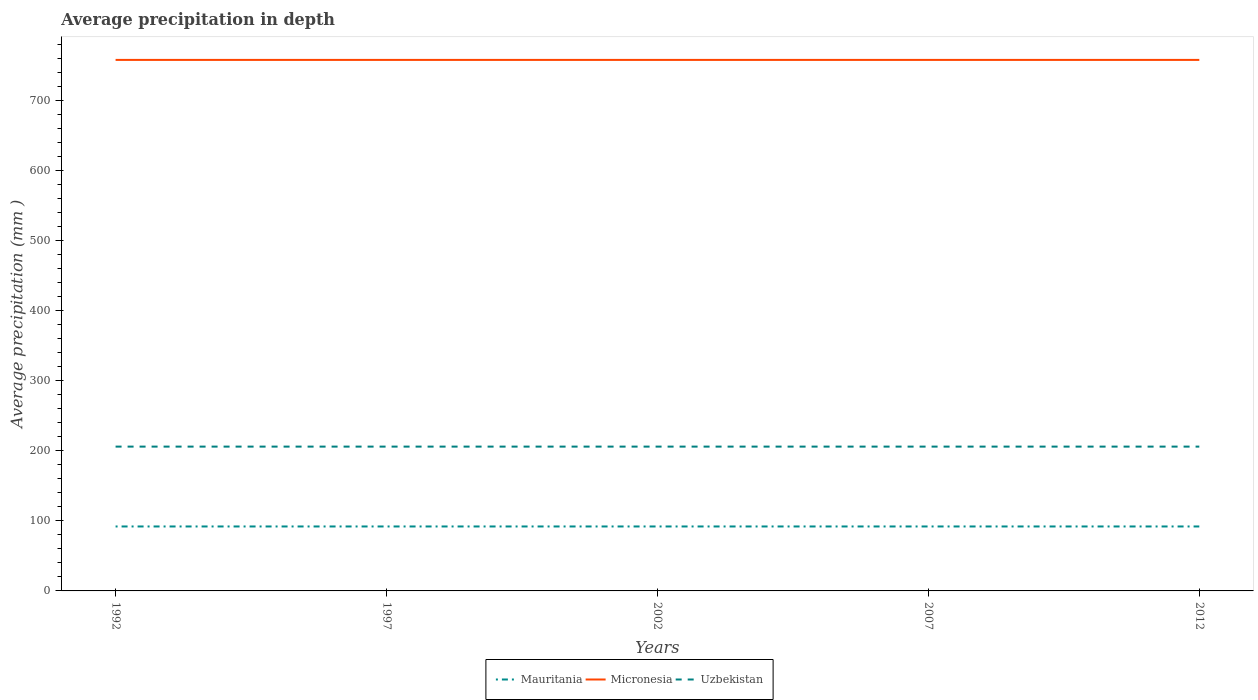How many different coloured lines are there?
Provide a short and direct response. 3. Is the number of lines equal to the number of legend labels?
Offer a very short reply. Yes. Across all years, what is the maximum average precipitation in Uzbekistan?
Ensure brevity in your answer.  206. In which year was the average precipitation in Mauritania maximum?
Offer a very short reply. 1992. What is the total average precipitation in Micronesia in the graph?
Offer a terse response. 0. What is the difference between the highest and the second highest average precipitation in Mauritania?
Your answer should be compact. 0. Is the average precipitation in Uzbekistan strictly greater than the average precipitation in Micronesia over the years?
Your response must be concise. Yes. Are the values on the major ticks of Y-axis written in scientific E-notation?
Offer a terse response. No. Does the graph contain any zero values?
Provide a succinct answer. No. Does the graph contain grids?
Your answer should be compact. No. How many legend labels are there?
Provide a short and direct response. 3. How are the legend labels stacked?
Ensure brevity in your answer.  Horizontal. What is the title of the graph?
Provide a short and direct response. Average precipitation in depth. What is the label or title of the Y-axis?
Give a very brief answer. Average precipitation (mm ). What is the Average precipitation (mm ) of Mauritania in 1992?
Provide a succinct answer. 92. What is the Average precipitation (mm ) of Micronesia in 1992?
Provide a succinct answer. 758. What is the Average precipitation (mm ) of Uzbekistan in 1992?
Your answer should be very brief. 206. What is the Average precipitation (mm ) of Mauritania in 1997?
Give a very brief answer. 92. What is the Average precipitation (mm ) in Micronesia in 1997?
Offer a very short reply. 758. What is the Average precipitation (mm ) of Uzbekistan in 1997?
Your answer should be compact. 206. What is the Average precipitation (mm ) in Mauritania in 2002?
Make the answer very short. 92. What is the Average precipitation (mm ) in Micronesia in 2002?
Your answer should be very brief. 758. What is the Average precipitation (mm ) of Uzbekistan in 2002?
Offer a terse response. 206. What is the Average precipitation (mm ) of Mauritania in 2007?
Give a very brief answer. 92. What is the Average precipitation (mm ) of Micronesia in 2007?
Provide a short and direct response. 758. What is the Average precipitation (mm ) of Uzbekistan in 2007?
Provide a short and direct response. 206. What is the Average precipitation (mm ) of Mauritania in 2012?
Offer a terse response. 92. What is the Average precipitation (mm ) of Micronesia in 2012?
Provide a short and direct response. 758. What is the Average precipitation (mm ) in Uzbekistan in 2012?
Provide a short and direct response. 206. Across all years, what is the maximum Average precipitation (mm ) in Mauritania?
Your response must be concise. 92. Across all years, what is the maximum Average precipitation (mm ) in Micronesia?
Make the answer very short. 758. Across all years, what is the maximum Average precipitation (mm ) in Uzbekistan?
Offer a very short reply. 206. Across all years, what is the minimum Average precipitation (mm ) in Mauritania?
Make the answer very short. 92. Across all years, what is the minimum Average precipitation (mm ) of Micronesia?
Your response must be concise. 758. Across all years, what is the minimum Average precipitation (mm ) in Uzbekistan?
Make the answer very short. 206. What is the total Average precipitation (mm ) of Mauritania in the graph?
Give a very brief answer. 460. What is the total Average precipitation (mm ) in Micronesia in the graph?
Offer a very short reply. 3790. What is the total Average precipitation (mm ) of Uzbekistan in the graph?
Provide a succinct answer. 1030. What is the difference between the Average precipitation (mm ) of Micronesia in 1992 and that in 1997?
Your answer should be compact. 0. What is the difference between the Average precipitation (mm ) of Uzbekistan in 1992 and that in 1997?
Your response must be concise. 0. What is the difference between the Average precipitation (mm ) of Micronesia in 1992 and that in 2002?
Your answer should be compact. 0. What is the difference between the Average precipitation (mm ) of Uzbekistan in 1992 and that in 2002?
Provide a short and direct response. 0. What is the difference between the Average precipitation (mm ) in Micronesia in 1992 and that in 2007?
Your answer should be very brief. 0. What is the difference between the Average precipitation (mm ) in Uzbekistan in 1992 and that in 2007?
Provide a succinct answer. 0. What is the difference between the Average precipitation (mm ) of Mauritania in 1992 and that in 2012?
Your response must be concise. 0. What is the difference between the Average precipitation (mm ) of Mauritania in 1997 and that in 2002?
Your response must be concise. 0. What is the difference between the Average precipitation (mm ) in Uzbekistan in 1997 and that in 2007?
Your answer should be very brief. 0. What is the difference between the Average precipitation (mm ) in Micronesia in 2002 and that in 2007?
Ensure brevity in your answer.  0. What is the difference between the Average precipitation (mm ) of Mauritania in 2002 and that in 2012?
Make the answer very short. 0. What is the difference between the Average precipitation (mm ) of Micronesia in 2002 and that in 2012?
Make the answer very short. 0. What is the difference between the Average precipitation (mm ) of Micronesia in 2007 and that in 2012?
Ensure brevity in your answer.  0. What is the difference between the Average precipitation (mm ) in Uzbekistan in 2007 and that in 2012?
Give a very brief answer. 0. What is the difference between the Average precipitation (mm ) of Mauritania in 1992 and the Average precipitation (mm ) of Micronesia in 1997?
Provide a succinct answer. -666. What is the difference between the Average precipitation (mm ) of Mauritania in 1992 and the Average precipitation (mm ) of Uzbekistan in 1997?
Make the answer very short. -114. What is the difference between the Average precipitation (mm ) of Micronesia in 1992 and the Average precipitation (mm ) of Uzbekistan in 1997?
Give a very brief answer. 552. What is the difference between the Average precipitation (mm ) in Mauritania in 1992 and the Average precipitation (mm ) in Micronesia in 2002?
Provide a short and direct response. -666. What is the difference between the Average precipitation (mm ) in Mauritania in 1992 and the Average precipitation (mm ) in Uzbekistan in 2002?
Ensure brevity in your answer.  -114. What is the difference between the Average precipitation (mm ) in Micronesia in 1992 and the Average precipitation (mm ) in Uzbekistan in 2002?
Offer a terse response. 552. What is the difference between the Average precipitation (mm ) in Mauritania in 1992 and the Average precipitation (mm ) in Micronesia in 2007?
Your answer should be very brief. -666. What is the difference between the Average precipitation (mm ) in Mauritania in 1992 and the Average precipitation (mm ) in Uzbekistan in 2007?
Your answer should be very brief. -114. What is the difference between the Average precipitation (mm ) in Micronesia in 1992 and the Average precipitation (mm ) in Uzbekistan in 2007?
Provide a short and direct response. 552. What is the difference between the Average precipitation (mm ) in Mauritania in 1992 and the Average precipitation (mm ) in Micronesia in 2012?
Offer a very short reply. -666. What is the difference between the Average precipitation (mm ) in Mauritania in 1992 and the Average precipitation (mm ) in Uzbekistan in 2012?
Offer a very short reply. -114. What is the difference between the Average precipitation (mm ) in Micronesia in 1992 and the Average precipitation (mm ) in Uzbekistan in 2012?
Your answer should be compact. 552. What is the difference between the Average precipitation (mm ) of Mauritania in 1997 and the Average precipitation (mm ) of Micronesia in 2002?
Offer a terse response. -666. What is the difference between the Average precipitation (mm ) in Mauritania in 1997 and the Average precipitation (mm ) in Uzbekistan in 2002?
Give a very brief answer. -114. What is the difference between the Average precipitation (mm ) of Micronesia in 1997 and the Average precipitation (mm ) of Uzbekistan in 2002?
Give a very brief answer. 552. What is the difference between the Average precipitation (mm ) of Mauritania in 1997 and the Average precipitation (mm ) of Micronesia in 2007?
Give a very brief answer. -666. What is the difference between the Average precipitation (mm ) in Mauritania in 1997 and the Average precipitation (mm ) in Uzbekistan in 2007?
Your response must be concise. -114. What is the difference between the Average precipitation (mm ) in Micronesia in 1997 and the Average precipitation (mm ) in Uzbekistan in 2007?
Offer a terse response. 552. What is the difference between the Average precipitation (mm ) in Mauritania in 1997 and the Average precipitation (mm ) in Micronesia in 2012?
Make the answer very short. -666. What is the difference between the Average precipitation (mm ) of Mauritania in 1997 and the Average precipitation (mm ) of Uzbekistan in 2012?
Your answer should be compact. -114. What is the difference between the Average precipitation (mm ) in Micronesia in 1997 and the Average precipitation (mm ) in Uzbekistan in 2012?
Make the answer very short. 552. What is the difference between the Average precipitation (mm ) in Mauritania in 2002 and the Average precipitation (mm ) in Micronesia in 2007?
Your response must be concise. -666. What is the difference between the Average precipitation (mm ) in Mauritania in 2002 and the Average precipitation (mm ) in Uzbekistan in 2007?
Provide a short and direct response. -114. What is the difference between the Average precipitation (mm ) of Micronesia in 2002 and the Average precipitation (mm ) of Uzbekistan in 2007?
Provide a short and direct response. 552. What is the difference between the Average precipitation (mm ) of Mauritania in 2002 and the Average precipitation (mm ) of Micronesia in 2012?
Offer a very short reply. -666. What is the difference between the Average precipitation (mm ) in Mauritania in 2002 and the Average precipitation (mm ) in Uzbekistan in 2012?
Make the answer very short. -114. What is the difference between the Average precipitation (mm ) of Micronesia in 2002 and the Average precipitation (mm ) of Uzbekistan in 2012?
Provide a succinct answer. 552. What is the difference between the Average precipitation (mm ) of Mauritania in 2007 and the Average precipitation (mm ) of Micronesia in 2012?
Keep it short and to the point. -666. What is the difference between the Average precipitation (mm ) in Mauritania in 2007 and the Average precipitation (mm ) in Uzbekistan in 2012?
Offer a very short reply. -114. What is the difference between the Average precipitation (mm ) in Micronesia in 2007 and the Average precipitation (mm ) in Uzbekistan in 2012?
Offer a terse response. 552. What is the average Average precipitation (mm ) in Mauritania per year?
Ensure brevity in your answer.  92. What is the average Average precipitation (mm ) of Micronesia per year?
Make the answer very short. 758. What is the average Average precipitation (mm ) of Uzbekistan per year?
Provide a short and direct response. 206. In the year 1992, what is the difference between the Average precipitation (mm ) in Mauritania and Average precipitation (mm ) in Micronesia?
Give a very brief answer. -666. In the year 1992, what is the difference between the Average precipitation (mm ) in Mauritania and Average precipitation (mm ) in Uzbekistan?
Provide a short and direct response. -114. In the year 1992, what is the difference between the Average precipitation (mm ) of Micronesia and Average precipitation (mm ) of Uzbekistan?
Provide a short and direct response. 552. In the year 1997, what is the difference between the Average precipitation (mm ) in Mauritania and Average precipitation (mm ) in Micronesia?
Offer a very short reply. -666. In the year 1997, what is the difference between the Average precipitation (mm ) in Mauritania and Average precipitation (mm ) in Uzbekistan?
Your answer should be compact. -114. In the year 1997, what is the difference between the Average precipitation (mm ) in Micronesia and Average precipitation (mm ) in Uzbekistan?
Offer a very short reply. 552. In the year 2002, what is the difference between the Average precipitation (mm ) in Mauritania and Average precipitation (mm ) in Micronesia?
Ensure brevity in your answer.  -666. In the year 2002, what is the difference between the Average precipitation (mm ) of Mauritania and Average precipitation (mm ) of Uzbekistan?
Your answer should be compact. -114. In the year 2002, what is the difference between the Average precipitation (mm ) in Micronesia and Average precipitation (mm ) in Uzbekistan?
Provide a short and direct response. 552. In the year 2007, what is the difference between the Average precipitation (mm ) in Mauritania and Average precipitation (mm ) in Micronesia?
Keep it short and to the point. -666. In the year 2007, what is the difference between the Average precipitation (mm ) in Mauritania and Average precipitation (mm ) in Uzbekistan?
Give a very brief answer. -114. In the year 2007, what is the difference between the Average precipitation (mm ) of Micronesia and Average precipitation (mm ) of Uzbekistan?
Offer a very short reply. 552. In the year 2012, what is the difference between the Average precipitation (mm ) of Mauritania and Average precipitation (mm ) of Micronesia?
Your answer should be very brief. -666. In the year 2012, what is the difference between the Average precipitation (mm ) in Mauritania and Average precipitation (mm ) in Uzbekistan?
Make the answer very short. -114. In the year 2012, what is the difference between the Average precipitation (mm ) of Micronesia and Average precipitation (mm ) of Uzbekistan?
Make the answer very short. 552. What is the ratio of the Average precipitation (mm ) of Mauritania in 1992 to that in 1997?
Your answer should be compact. 1. What is the ratio of the Average precipitation (mm ) of Micronesia in 1992 to that in 1997?
Provide a short and direct response. 1. What is the ratio of the Average precipitation (mm ) of Uzbekistan in 1992 to that in 1997?
Provide a succinct answer. 1. What is the ratio of the Average precipitation (mm ) of Mauritania in 1992 to that in 2002?
Your answer should be very brief. 1. What is the ratio of the Average precipitation (mm ) in Uzbekistan in 1992 to that in 2002?
Your answer should be very brief. 1. What is the ratio of the Average precipitation (mm ) of Mauritania in 1992 to that in 2007?
Provide a succinct answer. 1. What is the ratio of the Average precipitation (mm ) in Micronesia in 1992 to that in 2007?
Provide a short and direct response. 1. What is the ratio of the Average precipitation (mm ) of Uzbekistan in 1992 to that in 2007?
Offer a terse response. 1. What is the ratio of the Average precipitation (mm ) in Micronesia in 1992 to that in 2012?
Your answer should be very brief. 1. What is the ratio of the Average precipitation (mm ) of Mauritania in 1997 to that in 2002?
Your response must be concise. 1. What is the ratio of the Average precipitation (mm ) of Uzbekistan in 1997 to that in 2002?
Offer a terse response. 1. What is the ratio of the Average precipitation (mm ) in Mauritania in 1997 to that in 2007?
Provide a succinct answer. 1. What is the ratio of the Average precipitation (mm ) of Uzbekistan in 1997 to that in 2007?
Offer a very short reply. 1. What is the ratio of the Average precipitation (mm ) in Mauritania in 1997 to that in 2012?
Provide a succinct answer. 1. What is the ratio of the Average precipitation (mm ) in Mauritania in 2002 to that in 2007?
Your answer should be compact. 1. What is the ratio of the Average precipitation (mm ) in Uzbekistan in 2002 to that in 2012?
Offer a terse response. 1. What is the ratio of the Average precipitation (mm ) of Mauritania in 2007 to that in 2012?
Provide a short and direct response. 1. What is the difference between the highest and the lowest Average precipitation (mm ) of Uzbekistan?
Your answer should be compact. 0. 